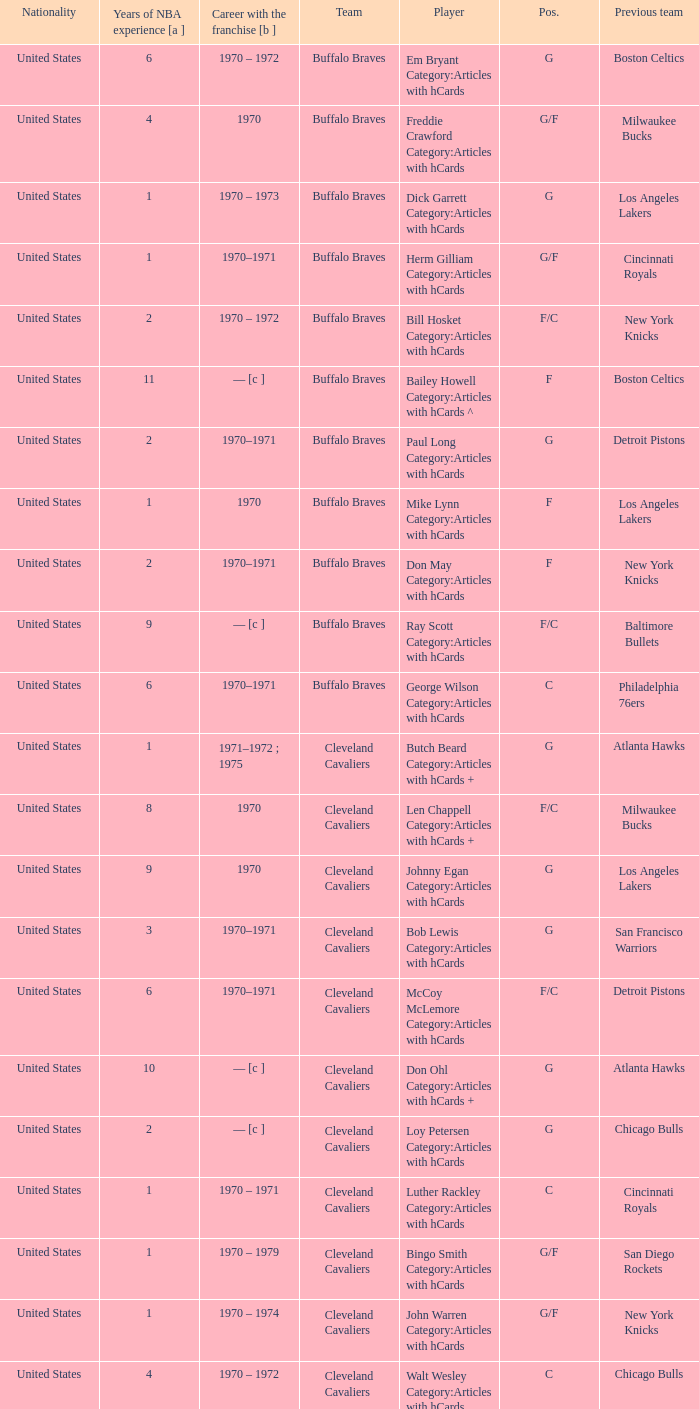Who is the player from the Buffalo Braves with the previous team Los Angeles Lakers and a career with the franchase in 1970? Mike Lynn Category:Articles with hCards. 